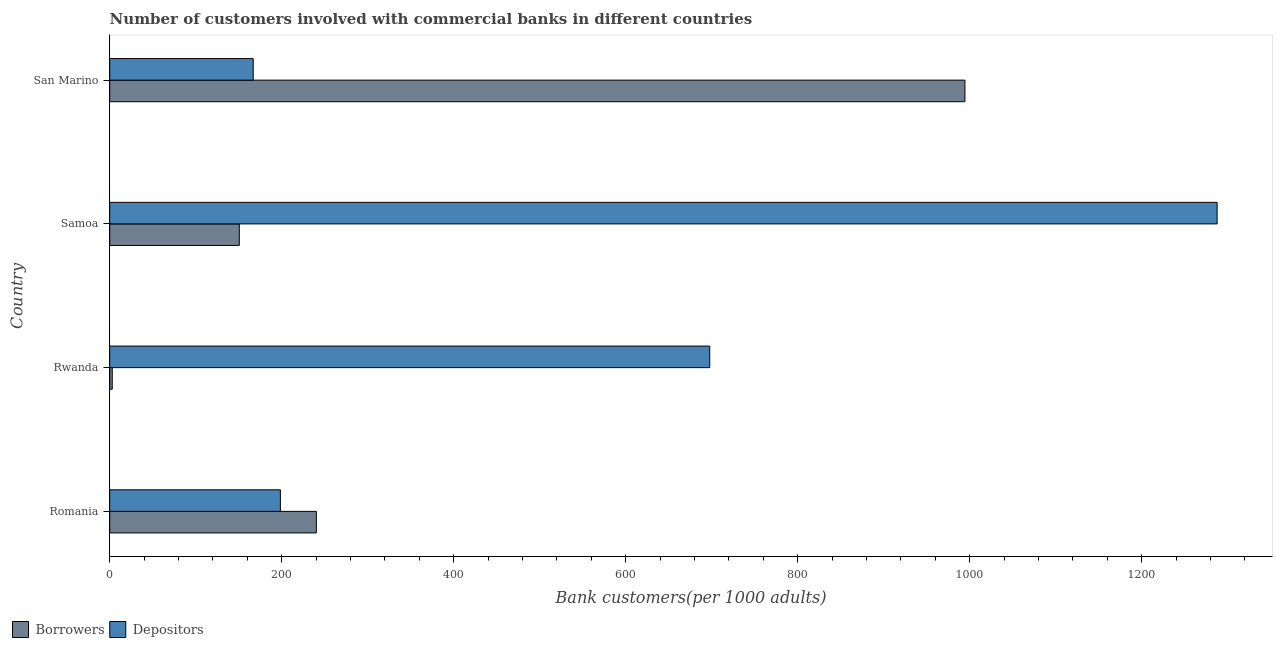How many different coloured bars are there?
Provide a short and direct response. 2. Are the number of bars per tick equal to the number of legend labels?
Provide a succinct answer. Yes. Are the number of bars on each tick of the Y-axis equal?
Your response must be concise. Yes. How many bars are there on the 3rd tick from the bottom?
Provide a succinct answer. 2. What is the label of the 1st group of bars from the top?
Make the answer very short. San Marino. What is the number of depositors in Romania?
Keep it short and to the point. 198.44. Across all countries, what is the maximum number of borrowers?
Your answer should be very brief. 994.42. Across all countries, what is the minimum number of borrowers?
Your response must be concise. 2.94. In which country was the number of borrowers maximum?
Provide a short and direct response. San Marino. In which country was the number of depositors minimum?
Keep it short and to the point. San Marino. What is the total number of depositors in the graph?
Offer a very short reply. 2350.58. What is the difference between the number of depositors in Romania and that in Rwanda?
Ensure brevity in your answer.  -499.24. What is the difference between the number of borrowers in Romania and the number of depositors in Samoa?
Your answer should be very brief. -1047.38. What is the average number of depositors per country?
Provide a succinct answer. 587.64. What is the difference between the number of depositors and number of borrowers in San Marino?
Provide a short and direct response. -827.59. What is the ratio of the number of borrowers in Romania to that in Samoa?
Provide a succinct answer. 1.59. Is the number of depositors in Romania less than that in Samoa?
Keep it short and to the point. Yes. Is the difference between the number of borrowers in Romania and San Marino greater than the difference between the number of depositors in Romania and San Marino?
Your answer should be very brief. No. What is the difference between the highest and the second highest number of borrowers?
Provide a short and direct response. 754.16. What is the difference between the highest and the lowest number of borrowers?
Offer a very short reply. 991.47. In how many countries, is the number of depositors greater than the average number of depositors taken over all countries?
Make the answer very short. 2. Is the sum of the number of borrowers in Romania and San Marino greater than the maximum number of depositors across all countries?
Provide a succinct answer. No. What does the 2nd bar from the top in Rwanda represents?
Offer a very short reply. Borrowers. What does the 2nd bar from the bottom in Rwanda represents?
Give a very brief answer. Depositors. How many countries are there in the graph?
Provide a short and direct response. 4. What is the difference between two consecutive major ticks on the X-axis?
Provide a succinct answer. 200. Does the graph contain grids?
Provide a short and direct response. No. Where does the legend appear in the graph?
Provide a succinct answer. Bottom left. What is the title of the graph?
Provide a short and direct response. Number of customers involved with commercial banks in different countries. What is the label or title of the X-axis?
Keep it short and to the point. Bank customers(per 1000 adults). What is the Bank customers(per 1000 adults) in Borrowers in Romania?
Offer a terse response. 240.26. What is the Bank customers(per 1000 adults) of Depositors in Romania?
Your answer should be compact. 198.44. What is the Bank customers(per 1000 adults) in Borrowers in Rwanda?
Give a very brief answer. 2.94. What is the Bank customers(per 1000 adults) in Depositors in Rwanda?
Make the answer very short. 697.68. What is the Bank customers(per 1000 adults) in Borrowers in Samoa?
Offer a very short reply. 150.68. What is the Bank customers(per 1000 adults) in Depositors in Samoa?
Provide a succinct answer. 1287.64. What is the Bank customers(per 1000 adults) of Borrowers in San Marino?
Your answer should be compact. 994.42. What is the Bank customers(per 1000 adults) in Depositors in San Marino?
Provide a short and direct response. 166.83. Across all countries, what is the maximum Bank customers(per 1000 adults) of Borrowers?
Give a very brief answer. 994.42. Across all countries, what is the maximum Bank customers(per 1000 adults) in Depositors?
Give a very brief answer. 1287.64. Across all countries, what is the minimum Bank customers(per 1000 adults) in Borrowers?
Keep it short and to the point. 2.94. Across all countries, what is the minimum Bank customers(per 1000 adults) in Depositors?
Offer a terse response. 166.83. What is the total Bank customers(per 1000 adults) in Borrowers in the graph?
Provide a short and direct response. 1388.29. What is the total Bank customers(per 1000 adults) of Depositors in the graph?
Offer a terse response. 2350.58. What is the difference between the Bank customers(per 1000 adults) in Borrowers in Romania and that in Rwanda?
Your answer should be very brief. 237.32. What is the difference between the Bank customers(per 1000 adults) in Depositors in Romania and that in Rwanda?
Offer a terse response. -499.24. What is the difference between the Bank customers(per 1000 adults) in Borrowers in Romania and that in Samoa?
Your response must be concise. 89.58. What is the difference between the Bank customers(per 1000 adults) of Depositors in Romania and that in Samoa?
Your answer should be very brief. -1089.2. What is the difference between the Bank customers(per 1000 adults) in Borrowers in Romania and that in San Marino?
Make the answer very short. -754.16. What is the difference between the Bank customers(per 1000 adults) of Depositors in Romania and that in San Marino?
Your response must be concise. 31.61. What is the difference between the Bank customers(per 1000 adults) of Borrowers in Rwanda and that in Samoa?
Provide a short and direct response. -147.73. What is the difference between the Bank customers(per 1000 adults) in Depositors in Rwanda and that in Samoa?
Offer a terse response. -589.96. What is the difference between the Bank customers(per 1000 adults) of Borrowers in Rwanda and that in San Marino?
Keep it short and to the point. -991.47. What is the difference between the Bank customers(per 1000 adults) in Depositors in Rwanda and that in San Marino?
Offer a terse response. 530.84. What is the difference between the Bank customers(per 1000 adults) in Borrowers in Samoa and that in San Marino?
Give a very brief answer. -843.74. What is the difference between the Bank customers(per 1000 adults) in Depositors in Samoa and that in San Marino?
Ensure brevity in your answer.  1120.81. What is the difference between the Bank customers(per 1000 adults) in Borrowers in Romania and the Bank customers(per 1000 adults) in Depositors in Rwanda?
Offer a very short reply. -457.42. What is the difference between the Bank customers(per 1000 adults) in Borrowers in Romania and the Bank customers(per 1000 adults) in Depositors in Samoa?
Provide a succinct answer. -1047.38. What is the difference between the Bank customers(per 1000 adults) of Borrowers in Romania and the Bank customers(per 1000 adults) of Depositors in San Marino?
Provide a short and direct response. 73.43. What is the difference between the Bank customers(per 1000 adults) in Borrowers in Rwanda and the Bank customers(per 1000 adults) in Depositors in Samoa?
Provide a succinct answer. -1284.69. What is the difference between the Bank customers(per 1000 adults) in Borrowers in Rwanda and the Bank customers(per 1000 adults) in Depositors in San Marino?
Offer a terse response. -163.89. What is the difference between the Bank customers(per 1000 adults) in Borrowers in Samoa and the Bank customers(per 1000 adults) in Depositors in San Marino?
Provide a short and direct response. -16.16. What is the average Bank customers(per 1000 adults) in Borrowers per country?
Make the answer very short. 347.07. What is the average Bank customers(per 1000 adults) of Depositors per country?
Ensure brevity in your answer.  587.64. What is the difference between the Bank customers(per 1000 adults) of Borrowers and Bank customers(per 1000 adults) of Depositors in Romania?
Your response must be concise. 41.82. What is the difference between the Bank customers(per 1000 adults) of Borrowers and Bank customers(per 1000 adults) of Depositors in Rwanda?
Your answer should be compact. -694.73. What is the difference between the Bank customers(per 1000 adults) of Borrowers and Bank customers(per 1000 adults) of Depositors in Samoa?
Offer a terse response. -1136.96. What is the difference between the Bank customers(per 1000 adults) in Borrowers and Bank customers(per 1000 adults) in Depositors in San Marino?
Make the answer very short. 827.58. What is the ratio of the Bank customers(per 1000 adults) in Borrowers in Romania to that in Rwanda?
Provide a short and direct response. 81.61. What is the ratio of the Bank customers(per 1000 adults) in Depositors in Romania to that in Rwanda?
Your answer should be very brief. 0.28. What is the ratio of the Bank customers(per 1000 adults) in Borrowers in Romania to that in Samoa?
Give a very brief answer. 1.59. What is the ratio of the Bank customers(per 1000 adults) in Depositors in Romania to that in Samoa?
Your response must be concise. 0.15. What is the ratio of the Bank customers(per 1000 adults) in Borrowers in Romania to that in San Marino?
Keep it short and to the point. 0.24. What is the ratio of the Bank customers(per 1000 adults) of Depositors in Romania to that in San Marino?
Provide a succinct answer. 1.19. What is the ratio of the Bank customers(per 1000 adults) of Borrowers in Rwanda to that in Samoa?
Provide a succinct answer. 0.02. What is the ratio of the Bank customers(per 1000 adults) in Depositors in Rwanda to that in Samoa?
Make the answer very short. 0.54. What is the ratio of the Bank customers(per 1000 adults) in Borrowers in Rwanda to that in San Marino?
Give a very brief answer. 0. What is the ratio of the Bank customers(per 1000 adults) in Depositors in Rwanda to that in San Marino?
Keep it short and to the point. 4.18. What is the ratio of the Bank customers(per 1000 adults) of Borrowers in Samoa to that in San Marino?
Make the answer very short. 0.15. What is the ratio of the Bank customers(per 1000 adults) in Depositors in Samoa to that in San Marino?
Make the answer very short. 7.72. What is the difference between the highest and the second highest Bank customers(per 1000 adults) of Borrowers?
Provide a succinct answer. 754.16. What is the difference between the highest and the second highest Bank customers(per 1000 adults) of Depositors?
Your answer should be compact. 589.96. What is the difference between the highest and the lowest Bank customers(per 1000 adults) in Borrowers?
Keep it short and to the point. 991.47. What is the difference between the highest and the lowest Bank customers(per 1000 adults) of Depositors?
Offer a very short reply. 1120.81. 